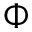Convert formula to latex. <formula><loc_0><loc_0><loc_500><loc_500>\Phi</formula> 